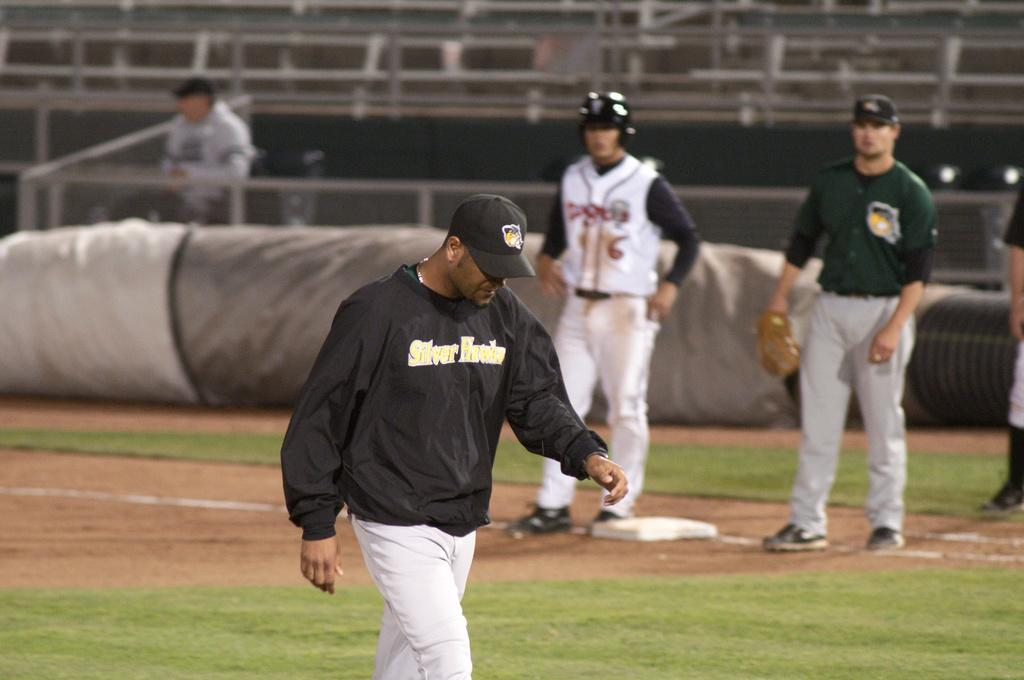<image>
Summarize the visual content of the image. A man on a baseball field wears a shirt that reads "Silver Hawks." 